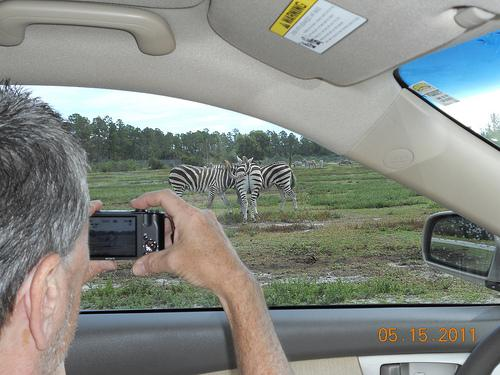Mention the main activity happening in the image and the subjects involved. A man is taking a picture of three zebras standing in a field with a small grey camera. Talk about the natural elements in proximity to the zebras in the image. There are trees in the distance and a patch of dirt on the ground near the zebras. What are the colors seen on the hair of the person present in the image? The man has dark and light grey hair and a beard. Enumerate some key highlights of the image that involve the man, the zebras, and their surroundings. Man holding a camera, zebras with black and white stripes, green grass, trees, and a car with a mirror. Write about an accessory present in the man's hand and provide a brief description. The man is holding a dark grey camera with two hands in order to take pictures. How can the appearance of the zebras be described? The zebras have black and white stripes and a swaying tail. Describe the setting in which the zebras are standing. Zebras are standing on a field with green grass, dirt, and puddles of water. Narrate the different details observed on the car in the image. A mirror is attached to the car, with a visor on top, and a sticker on the windshield. Mention any animals seen other than the zebras in the image. There are some unidentified animals behind the zebras in the field. What does the car in the image consist of, from the details observed in the given list? The car's interior is grey, with a left side mirror, rear view mirror, visor, and a warning label. 